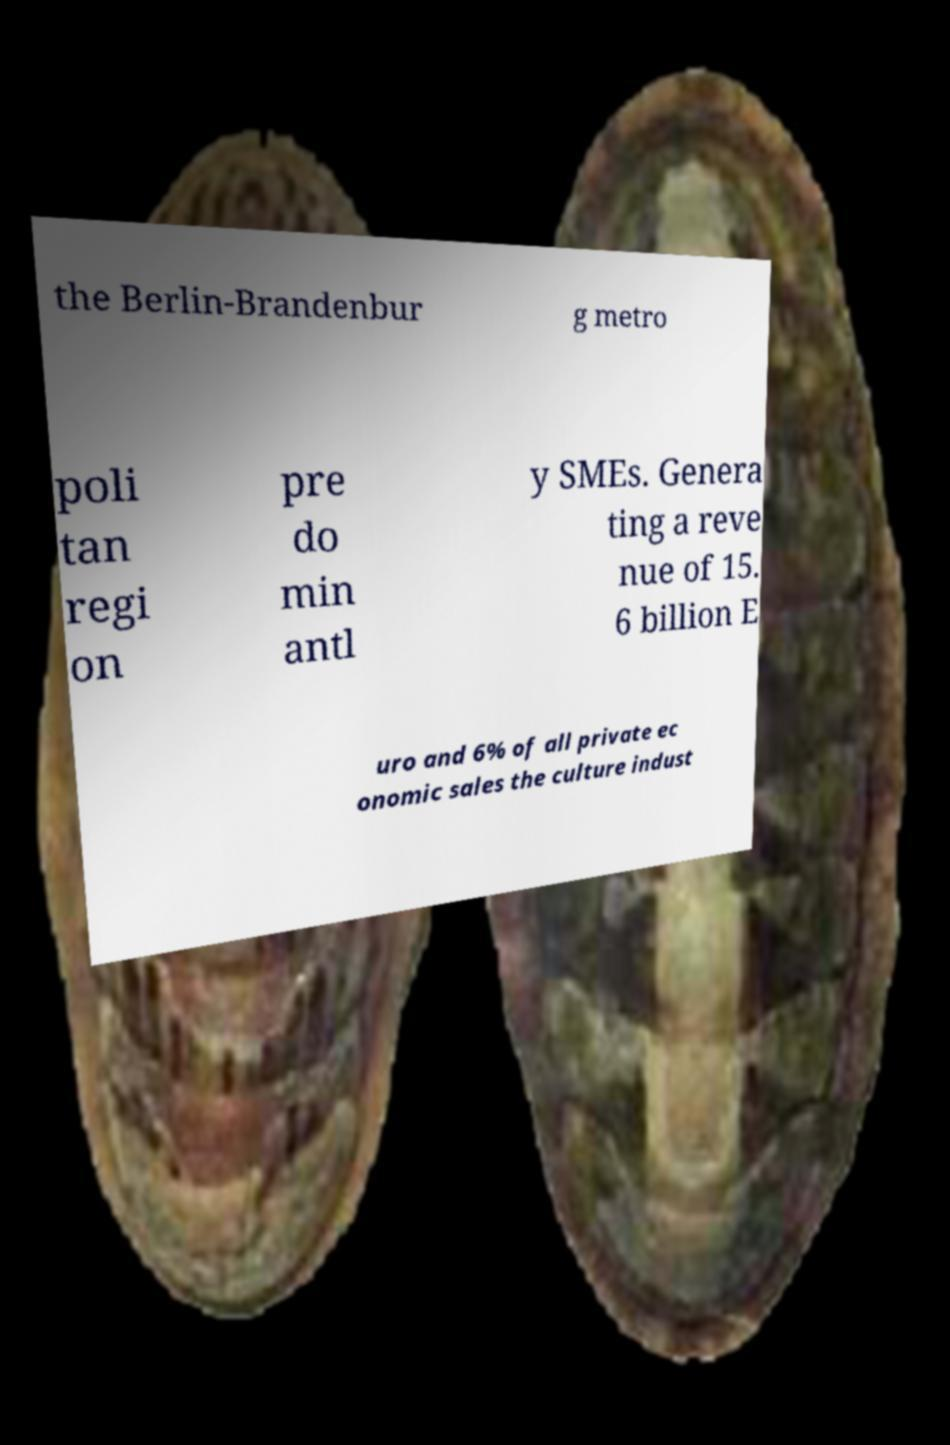There's text embedded in this image that I need extracted. Can you transcribe it verbatim? the Berlin-Brandenbur g metro poli tan regi on pre do min antl y SMEs. Genera ting a reve nue of 15. 6 billion E uro and 6% of all private ec onomic sales the culture indust 